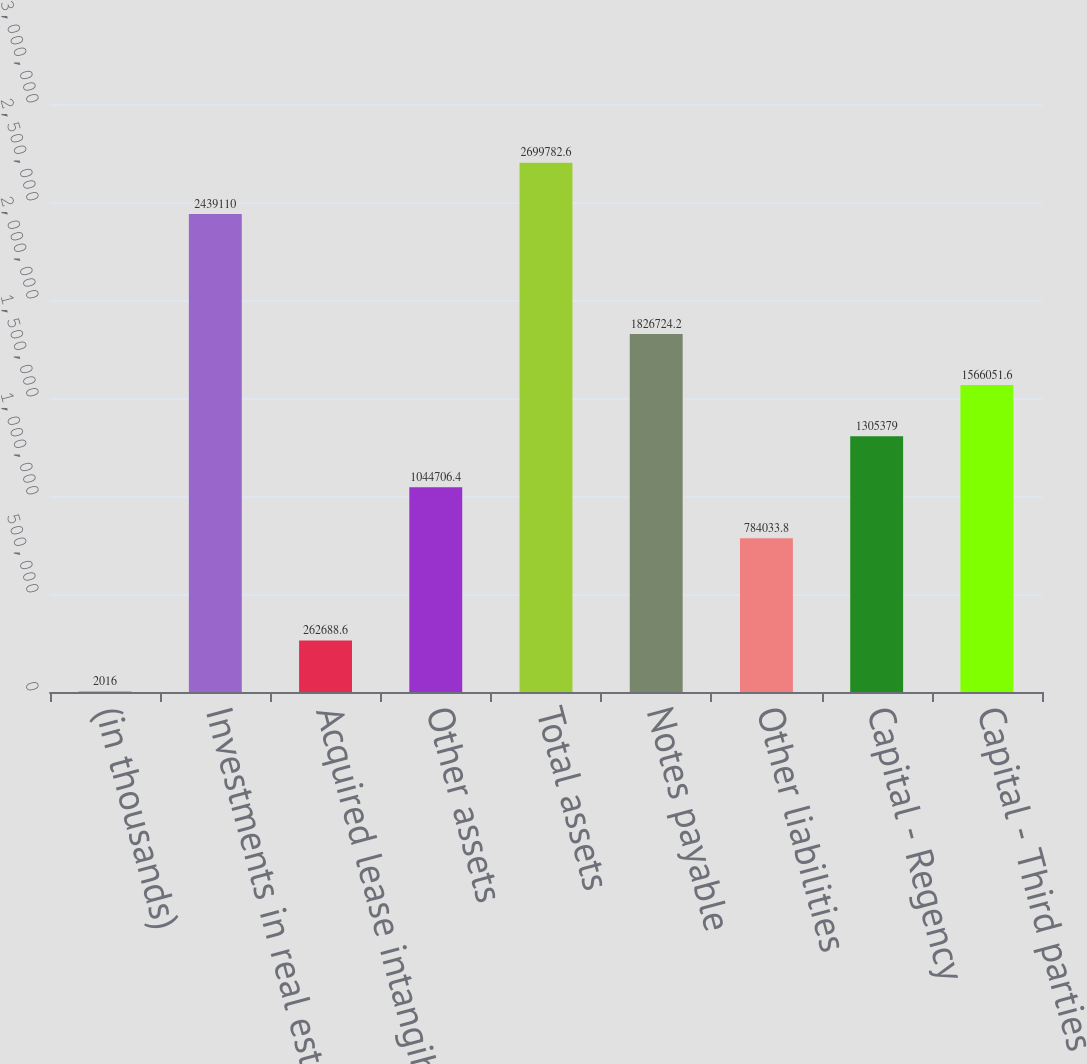Convert chart to OTSL. <chart><loc_0><loc_0><loc_500><loc_500><bar_chart><fcel>(in thousands)<fcel>Investments in real estate net<fcel>Acquired lease intangible<fcel>Other assets<fcel>Total assets<fcel>Notes payable<fcel>Other liabilities<fcel>Capital - Regency<fcel>Capital - Third parties<nl><fcel>2016<fcel>2.43911e+06<fcel>262689<fcel>1.04471e+06<fcel>2.69978e+06<fcel>1.82672e+06<fcel>784034<fcel>1.30538e+06<fcel>1.56605e+06<nl></chart> 